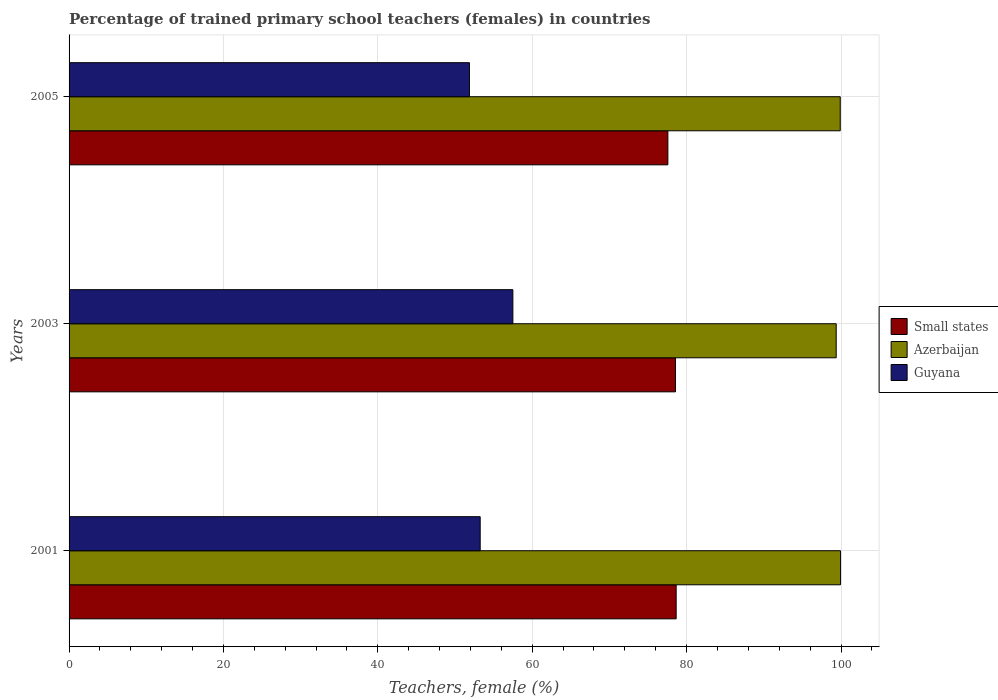How many groups of bars are there?
Your answer should be very brief. 3. Are the number of bars per tick equal to the number of legend labels?
Offer a terse response. Yes. Are the number of bars on each tick of the Y-axis equal?
Offer a terse response. Yes. What is the percentage of trained primary school teachers (females) in Azerbaijan in 2005?
Keep it short and to the point. 99.9. Across all years, what is the maximum percentage of trained primary school teachers (females) in Guyana?
Provide a short and direct response. 57.49. Across all years, what is the minimum percentage of trained primary school teachers (females) in Guyana?
Ensure brevity in your answer.  51.87. In which year was the percentage of trained primary school teachers (females) in Azerbaijan minimum?
Your answer should be very brief. 2003. What is the total percentage of trained primary school teachers (females) in Azerbaijan in the graph?
Offer a very short reply. 299.22. What is the difference between the percentage of trained primary school teachers (females) in Azerbaijan in 2001 and that in 2005?
Your answer should be very brief. 0.04. What is the difference between the percentage of trained primary school teachers (females) in Guyana in 2005 and the percentage of trained primary school teachers (females) in Small states in 2003?
Your answer should be compact. -26.69. What is the average percentage of trained primary school teachers (females) in Azerbaijan per year?
Make the answer very short. 99.74. In the year 2005, what is the difference between the percentage of trained primary school teachers (females) in Guyana and percentage of trained primary school teachers (females) in Small states?
Provide a short and direct response. -25.71. What is the ratio of the percentage of trained primary school teachers (females) in Small states in 2003 to that in 2005?
Your answer should be compact. 1.01. What is the difference between the highest and the second highest percentage of trained primary school teachers (females) in Small states?
Your response must be concise. 0.09. What is the difference between the highest and the lowest percentage of trained primary school teachers (females) in Guyana?
Provide a succinct answer. 5.63. Is the sum of the percentage of trained primary school teachers (females) in Azerbaijan in 2001 and 2005 greater than the maximum percentage of trained primary school teachers (females) in Guyana across all years?
Offer a very short reply. Yes. What does the 3rd bar from the top in 2003 represents?
Your answer should be compact. Small states. What does the 1st bar from the bottom in 2003 represents?
Provide a succinct answer. Small states. Does the graph contain any zero values?
Offer a very short reply. No. How many legend labels are there?
Your answer should be very brief. 3. How are the legend labels stacked?
Provide a succinct answer. Vertical. What is the title of the graph?
Give a very brief answer. Percentage of trained primary school teachers (females) in countries. What is the label or title of the X-axis?
Keep it short and to the point. Teachers, female (%). What is the Teachers, female (%) of Small states in 2001?
Ensure brevity in your answer.  78.64. What is the Teachers, female (%) in Azerbaijan in 2001?
Your response must be concise. 99.94. What is the Teachers, female (%) in Guyana in 2001?
Your answer should be compact. 53.26. What is the Teachers, female (%) in Small states in 2003?
Offer a very short reply. 78.56. What is the Teachers, female (%) in Azerbaijan in 2003?
Make the answer very short. 99.38. What is the Teachers, female (%) in Guyana in 2003?
Provide a short and direct response. 57.49. What is the Teachers, female (%) of Small states in 2005?
Provide a succinct answer. 77.57. What is the Teachers, female (%) in Azerbaijan in 2005?
Provide a short and direct response. 99.9. What is the Teachers, female (%) in Guyana in 2005?
Your answer should be very brief. 51.87. Across all years, what is the maximum Teachers, female (%) in Small states?
Give a very brief answer. 78.64. Across all years, what is the maximum Teachers, female (%) in Azerbaijan?
Ensure brevity in your answer.  99.94. Across all years, what is the maximum Teachers, female (%) of Guyana?
Keep it short and to the point. 57.49. Across all years, what is the minimum Teachers, female (%) of Small states?
Provide a short and direct response. 77.57. Across all years, what is the minimum Teachers, female (%) in Azerbaijan?
Your answer should be compact. 99.38. Across all years, what is the minimum Teachers, female (%) in Guyana?
Ensure brevity in your answer.  51.87. What is the total Teachers, female (%) in Small states in the graph?
Your answer should be compact. 234.77. What is the total Teachers, female (%) in Azerbaijan in the graph?
Offer a terse response. 299.22. What is the total Teachers, female (%) in Guyana in the graph?
Your answer should be very brief. 162.61. What is the difference between the Teachers, female (%) in Small states in 2001 and that in 2003?
Your answer should be very brief. 0.09. What is the difference between the Teachers, female (%) in Azerbaijan in 2001 and that in 2003?
Make the answer very short. 0.56. What is the difference between the Teachers, female (%) of Guyana in 2001 and that in 2003?
Give a very brief answer. -4.23. What is the difference between the Teachers, female (%) of Small states in 2001 and that in 2005?
Your answer should be very brief. 1.07. What is the difference between the Teachers, female (%) of Azerbaijan in 2001 and that in 2005?
Provide a short and direct response. 0.04. What is the difference between the Teachers, female (%) in Guyana in 2001 and that in 2005?
Your answer should be compact. 1.39. What is the difference between the Teachers, female (%) of Small states in 2003 and that in 2005?
Provide a succinct answer. 0.99. What is the difference between the Teachers, female (%) of Azerbaijan in 2003 and that in 2005?
Provide a succinct answer. -0.53. What is the difference between the Teachers, female (%) of Guyana in 2003 and that in 2005?
Your answer should be very brief. 5.63. What is the difference between the Teachers, female (%) in Small states in 2001 and the Teachers, female (%) in Azerbaijan in 2003?
Provide a succinct answer. -20.73. What is the difference between the Teachers, female (%) of Small states in 2001 and the Teachers, female (%) of Guyana in 2003?
Your response must be concise. 21.15. What is the difference between the Teachers, female (%) in Azerbaijan in 2001 and the Teachers, female (%) in Guyana in 2003?
Give a very brief answer. 42.45. What is the difference between the Teachers, female (%) of Small states in 2001 and the Teachers, female (%) of Azerbaijan in 2005?
Give a very brief answer. -21.26. What is the difference between the Teachers, female (%) of Small states in 2001 and the Teachers, female (%) of Guyana in 2005?
Offer a terse response. 26.78. What is the difference between the Teachers, female (%) of Azerbaijan in 2001 and the Teachers, female (%) of Guyana in 2005?
Your answer should be very brief. 48.07. What is the difference between the Teachers, female (%) in Small states in 2003 and the Teachers, female (%) in Azerbaijan in 2005?
Make the answer very short. -21.35. What is the difference between the Teachers, female (%) of Small states in 2003 and the Teachers, female (%) of Guyana in 2005?
Make the answer very short. 26.69. What is the difference between the Teachers, female (%) of Azerbaijan in 2003 and the Teachers, female (%) of Guyana in 2005?
Offer a terse response. 47.51. What is the average Teachers, female (%) in Small states per year?
Your answer should be compact. 78.26. What is the average Teachers, female (%) in Azerbaijan per year?
Provide a short and direct response. 99.74. What is the average Teachers, female (%) in Guyana per year?
Give a very brief answer. 54.2. In the year 2001, what is the difference between the Teachers, female (%) of Small states and Teachers, female (%) of Azerbaijan?
Give a very brief answer. -21.3. In the year 2001, what is the difference between the Teachers, female (%) of Small states and Teachers, female (%) of Guyana?
Give a very brief answer. 25.39. In the year 2001, what is the difference between the Teachers, female (%) in Azerbaijan and Teachers, female (%) in Guyana?
Ensure brevity in your answer.  46.68. In the year 2003, what is the difference between the Teachers, female (%) of Small states and Teachers, female (%) of Azerbaijan?
Provide a short and direct response. -20.82. In the year 2003, what is the difference between the Teachers, female (%) of Small states and Teachers, female (%) of Guyana?
Offer a terse response. 21.07. In the year 2003, what is the difference between the Teachers, female (%) of Azerbaijan and Teachers, female (%) of Guyana?
Your response must be concise. 41.89. In the year 2005, what is the difference between the Teachers, female (%) in Small states and Teachers, female (%) in Azerbaijan?
Offer a very short reply. -22.33. In the year 2005, what is the difference between the Teachers, female (%) of Small states and Teachers, female (%) of Guyana?
Offer a terse response. 25.71. In the year 2005, what is the difference between the Teachers, female (%) in Azerbaijan and Teachers, female (%) in Guyana?
Your response must be concise. 48.04. What is the ratio of the Teachers, female (%) in Azerbaijan in 2001 to that in 2003?
Offer a very short reply. 1.01. What is the ratio of the Teachers, female (%) in Guyana in 2001 to that in 2003?
Your response must be concise. 0.93. What is the ratio of the Teachers, female (%) of Small states in 2001 to that in 2005?
Offer a very short reply. 1.01. What is the ratio of the Teachers, female (%) of Guyana in 2001 to that in 2005?
Give a very brief answer. 1.03. What is the ratio of the Teachers, female (%) in Small states in 2003 to that in 2005?
Give a very brief answer. 1.01. What is the ratio of the Teachers, female (%) of Azerbaijan in 2003 to that in 2005?
Give a very brief answer. 0.99. What is the ratio of the Teachers, female (%) in Guyana in 2003 to that in 2005?
Give a very brief answer. 1.11. What is the difference between the highest and the second highest Teachers, female (%) in Small states?
Ensure brevity in your answer.  0.09. What is the difference between the highest and the second highest Teachers, female (%) of Azerbaijan?
Your answer should be compact. 0.04. What is the difference between the highest and the second highest Teachers, female (%) of Guyana?
Your response must be concise. 4.23. What is the difference between the highest and the lowest Teachers, female (%) of Small states?
Provide a succinct answer. 1.07. What is the difference between the highest and the lowest Teachers, female (%) of Azerbaijan?
Your answer should be very brief. 0.56. What is the difference between the highest and the lowest Teachers, female (%) in Guyana?
Offer a terse response. 5.63. 